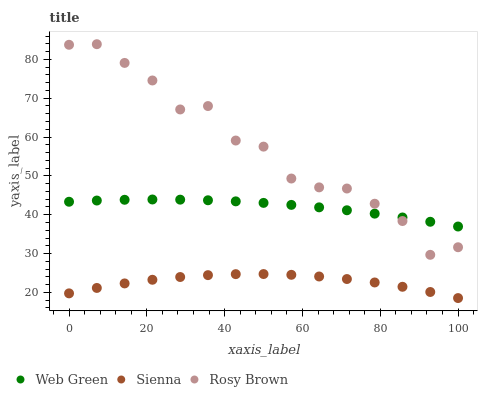Does Sienna have the minimum area under the curve?
Answer yes or no. Yes. Does Rosy Brown have the maximum area under the curve?
Answer yes or no. Yes. Does Web Green have the minimum area under the curve?
Answer yes or no. No. Does Web Green have the maximum area under the curve?
Answer yes or no. No. Is Web Green the smoothest?
Answer yes or no. Yes. Is Rosy Brown the roughest?
Answer yes or no. Yes. Is Rosy Brown the smoothest?
Answer yes or no. No. Is Web Green the roughest?
Answer yes or no. No. Does Sienna have the lowest value?
Answer yes or no. Yes. Does Rosy Brown have the lowest value?
Answer yes or no. No. Does Rosy Brown have the highest value?
Answer yes or no. Yes. Does Web Green have the highest value?
Answer yes or no. No. Is Sienna less than Rosy Brown?
Answer yes or no. Yes. Is Web Green greater than Sienna?
Answer yes or no. Yes. Does Rosy Brown intersect Web Green?
Answer yes or no. Yes. Is Rosy Brown less than Web Green?
Answer yes or no. No. Is Rosy Brown greater than Web Green?
Answer yes or no. No. Does Sienna intersect Rosy Brown?
Answer yes or no. No. 